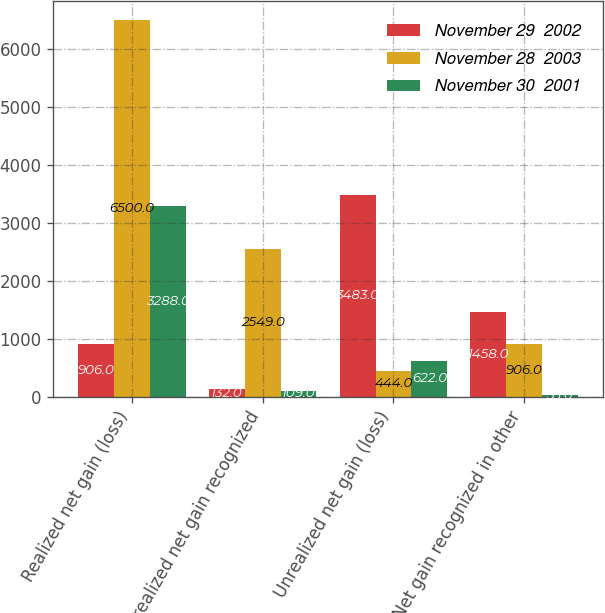Convert chart. <chart><loc_0><loc_0><loc_500><loc_500><stacked_bar_chart><ecel><fcel>Realized net gain (loss)<fcel>Unrealized net gain recognized<fcel>Unrealized net gain (loss)<fcel>Net gain recognized in other<nl><fcel>November 29  2002<fcel>906<fcel>132<fcel>3483<fcel>1458<nl><fcel>November 28  2003<fcel>6500<fcel>2549<fcel>444<fcel>906<nl><fcel>November 30  2001<fcel>3288<fcel>109<fcel>622<fcel>33<nl></chart> 